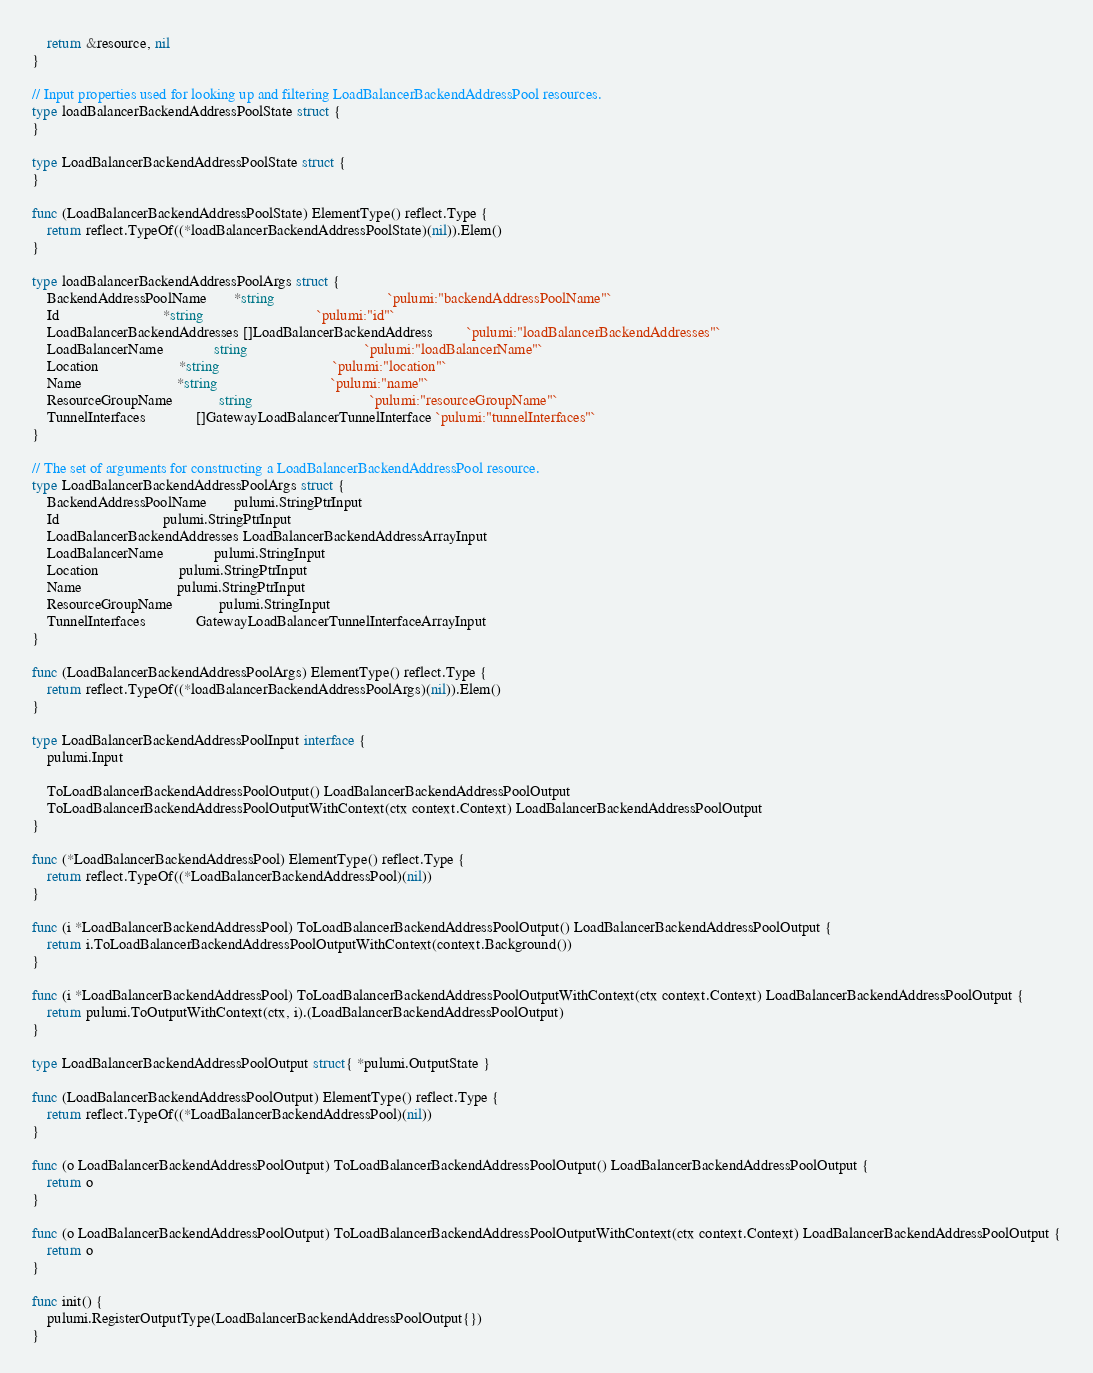<code> <loc_0><loc_0><loc_500><loc_500><_Go_>	return &resource, nil
}

// Input properties used for looking up and filtering LoadBalancerBackendAddressPool resources.
type loadBalancerBackendAddressPoolState struct {
}

type LoadBalancerBackendAddressPoolState struct {
}

func (LoadBalancerBackendAddressPoolState) ElementType() reflect.Type {
	return reflect.TypeOf((*loadBalancerBackendAddressPoolState)(nil)).Elem()
}

type loadBalancerBackendAddressPoolArgs struct {
	BackendAddressPoolName       *string                              `pulumi:"backendAddressPoolName"`
	Id                           *string                              `pulumi:"id"`
	LoadBalancerBackendAddresses []LoadBalancerBackendAddress         `pulumi:"loadBalancerBackendAddresses"`
	LoadBalancerName             string                               `pulumi:"loadBalancerName"`
	Location                     *string                              `pulumi:"location"`
	Name                         *string                              `pulumi:"name"`
	ResourceGroupName            string                               `pulumi:"resourceGroupName"`
	TunnelInterfaces             []GatewayLoadBalancerTunnelInterface `pulumi:"tunnelInterfaces"`
}

// The set of arguments for constructing a LoadBalancerBackendAddressPool resource.
type LoadBalancerBackendAddressPoolArgs struct {
	BackendAddressPoolName       pulumi.StringPtrInput
	Id                           pulumi.StringPtrInput
	LoadBalancerBackendAddresses LoadBalancerBackendAddressArrayInput
	LoadBalancerName             pulumi.StringInput
	Location                     pulumi.StringPtrInput
	Name                         pulumi.StringPtrInput
	ResourceGroupName            pulumi.StringInput
	TunnelInterfaces             GatewayLoadBalancerTunnelInterfaceArrayInput
}

func (LoadBalancerBackendAddressPoolArgs) ElementType() reflect.Type {
	return reflect.TypeOf((*loadBalancerBackendAddressPoolArgs)(nil)).Elem()
}

type LoadBalancerBackendAddressPoolInput interface {
	pulumi.Input

	ToLoadBalancerBackendAddressPoolOutput() LoadBalancerBackendAddressPoolOutput
	ToLoadBalancerBackendAddressPoolOutputWithContext(ctx context.Context) LoadBalancerBackendAddressPoolOutput
}

func (*LoadBalancerBackendAddressPool) ElementType() reflect.Type {
	return reflect.TypeOf((*LoadBalancerBackendAddressPool)(nil))
}

func (i *LoadBalancerBackendAddressPool) ToLoadBalancerBackendAddressPoolOutput() LoadBalancerBackendAddressPoolOutput {
	return i.ToLoadBalancerBackendAddressPoolOutputWithContext(context.Background())
}

func (i *LoadBalancerBackendAddressPool) ToLoadBalancerBackendAddressPoolOutputWithContext(ctx context.Context) LoadBalancerBackendAddressPoolOutput {
	return pulumi.ToOutputWithContext(ctx, i).(LoadBalancerBackendAddressPoolOutput)
}

type LoadBalancerBackendAddressPoolOutput struct{ *pulumi.OutputState }

func (LoadBalancerBackendAddressPoolOutput) ElementType() reflect.Type {
	return reflect.TypeOf((*LoadBalancerBackendAddressPool)(nil))
}

func (o LoadBalancerBackendAddressPoolOutput) ToLoadBalancerBackendAddressPoolOutput() LoadBalancerBackendAddressPoolOutput {
	return o
}

func (o LoadBalancerBackendAddressPoolOutput) ToLoadBalancerBackendAddressPoolOutputWithContext(ctx context.Context) LoadBalancerBackendAddressPoolOutput {
	return o
}

func init() {
	pulumi.RegisterOutputType(LoadBalancerBackendAddressPoolOutput{})
}
</code> 